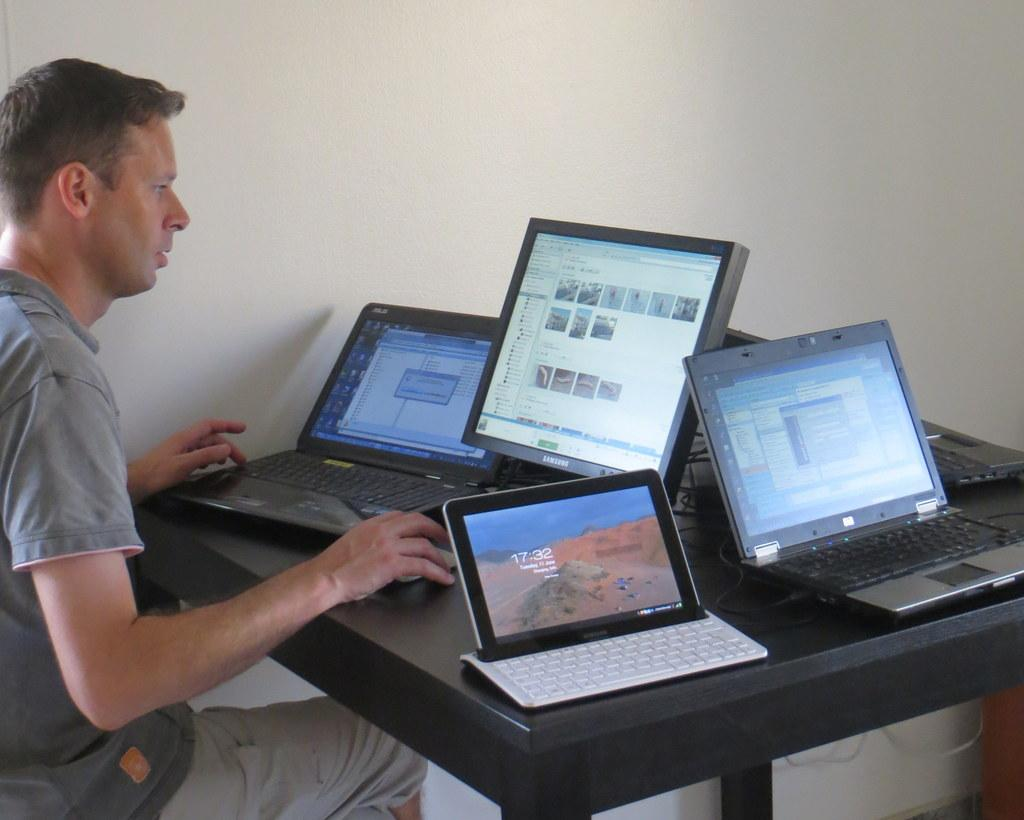What is the man in the image doing? The man is sitting in the chair in the image. What is located behind the man in the image? There is a wall in the background of the image. What is on the table in front of the man? There are three laptops and a computer monitor on the table. What type of robin can be seen in the scene in the image? There is no robin present in the image; it is an indoor setting with a man, a table, laptops, and a computer monitor. 